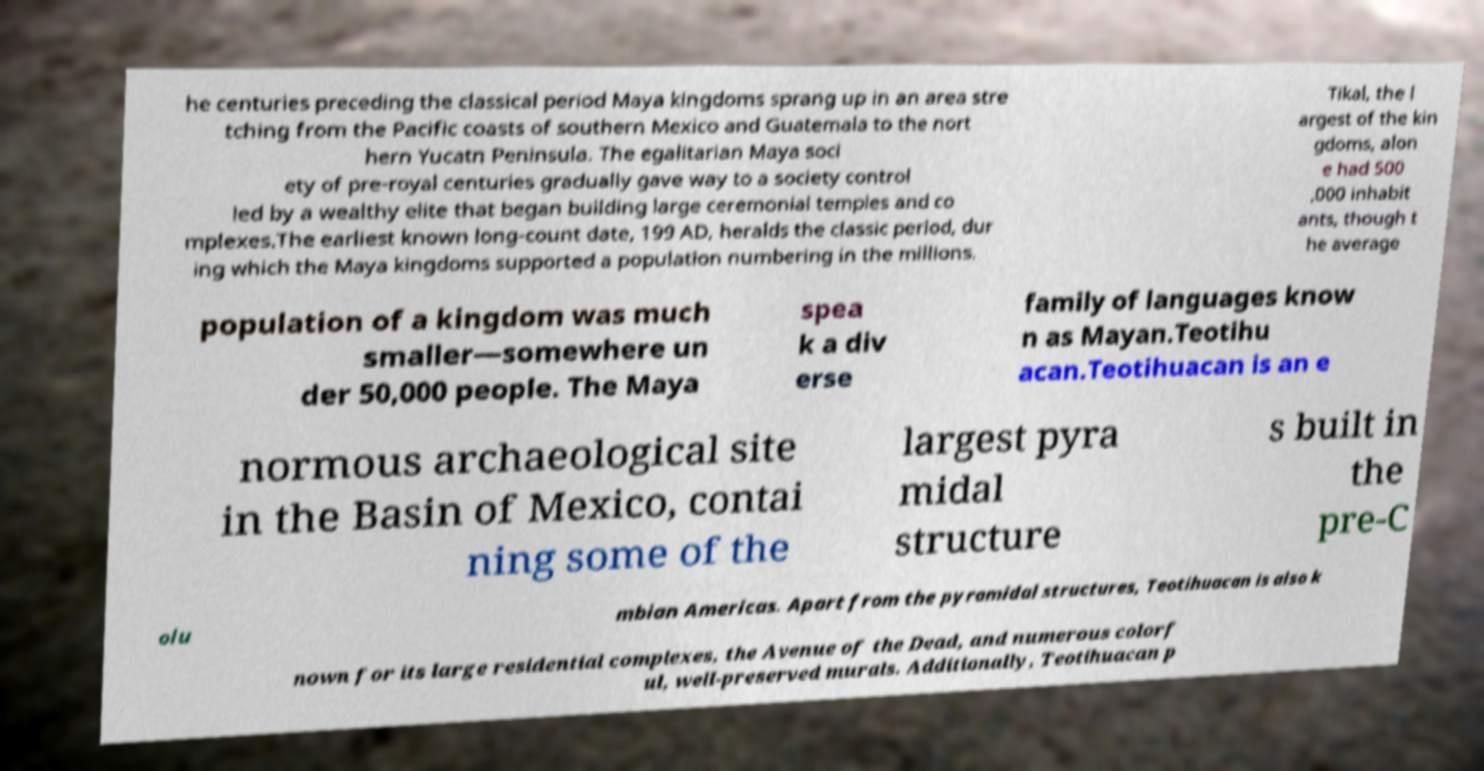Please read and relay the text visible in this image. What does it say? he centuries preceding the classical period Maya kingdoms sprang up in an area stre tching from the Pacific coasts of southern Mexico and Guatemala to the nort hern Yucatn Peninsula. The egalitarian Maya soci ety of pre-royal centuries gradually gave way to a society control led by a wealthy elite that began building large ceremonial temples and co mplexes.The earliest known long-count date, 199 AD, heralds the classic period, dur ing which the Maya kingdoms supported a population numbering in the millions. Tikal, the l argest of the kin gdoms, alon e had 500 ,000 inhabit ants, though t he average population of a kingdom was much smaller—somewhere un der 50,000 people. The Maya spea k a div erse family of languages know n as Mayan.Teotihu acan.Teotihuacan is an e normous archaeological site in the Basin of Mexico, contai ning some of the largest pyra midal structure s built in the pre-C olu mbian Americas. Apart from the pyramidal structures, Teotihuacan is also k nown for its large residential complexes, the Avenue of the Dead, and numerous colorf ul, well-preserved murals. Additionally, Teotihuacan p 